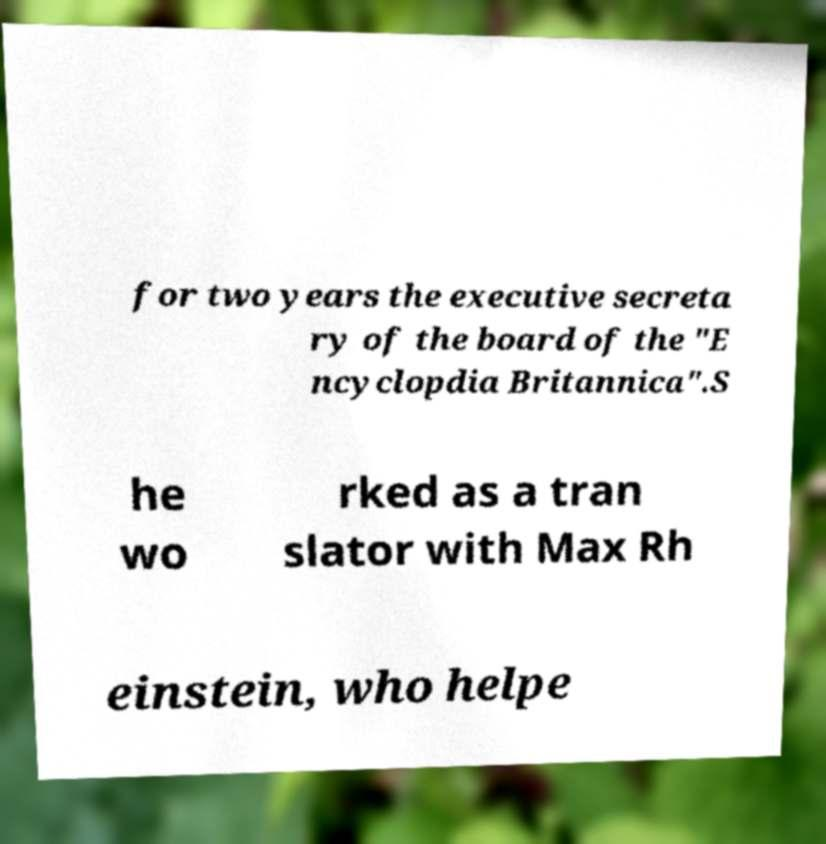Please identify and transcribe the text found in this image. for two years the executive secreta ry of the board of the "E ncyclopdia Britannica".S he wo rked as a tran slator with Max Rh einstein, who helpe 